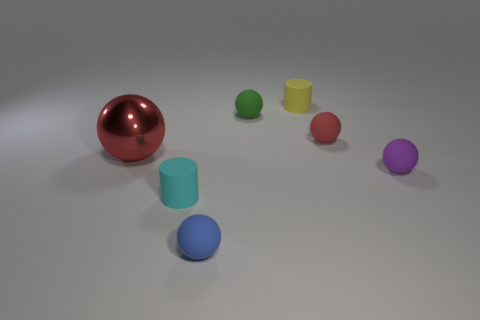Subtract all matte spheres. How many spheres are left? 1 Add 1 big gray rubber things. How many objects exist? 8 Add 5 large matte balls. How many large matte balls exist? 5 Subtract all yellow cylinders. How many cylinders are left? 1 Subtract 0 cyan balls. How many objects are left? 7 Subtract all cylinders. How many objects are left? 5 Subtract 3 balls. How many balls are left? 2 Subtract all red cylinders. Subtract all blue balls. How many cylinders are left? 2 Subtract all cyan cylinders. How many green spheres are left? 1 Subtract all small metal balls. Subtract all small red matte spheres. How many objects are left? 6 